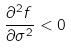Convert formula to latex. <formula><loc_0><loc_0><loc_500><loc_500>\frac { \partial ^ { 2 } f } { \partial \sigma ^ { 2 } } < 0</formula> 